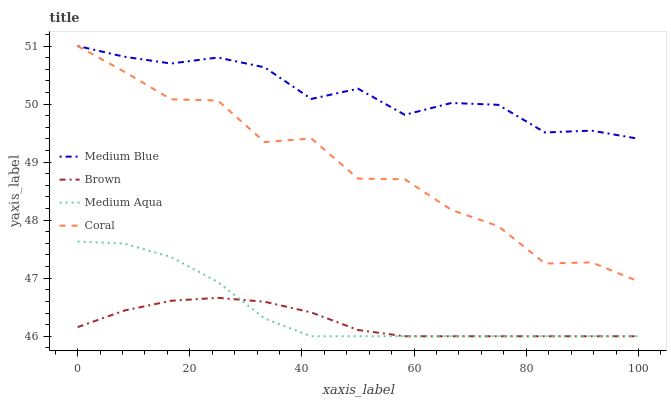Does Coral have the minimum area under the curve?
Answer yes or no. No. Does Coral have the maximum area under the curve?
Answer yes or no. No. Is Coral the smoothest?
Answer yes or no. No. Is Brown the roughest?
Answer yes or no. No. Does Coral have the lowest value?
Answer yes or no. No. Does Brown have the highest value?
Answer yes or no. No. Is Brown less than Coral?
Answer yes or no. Yes. Is Medium Blue greater than Brown?
Answer yes or no. Yes. Does Brown intersect Coral?
Answer yes or no. No. 